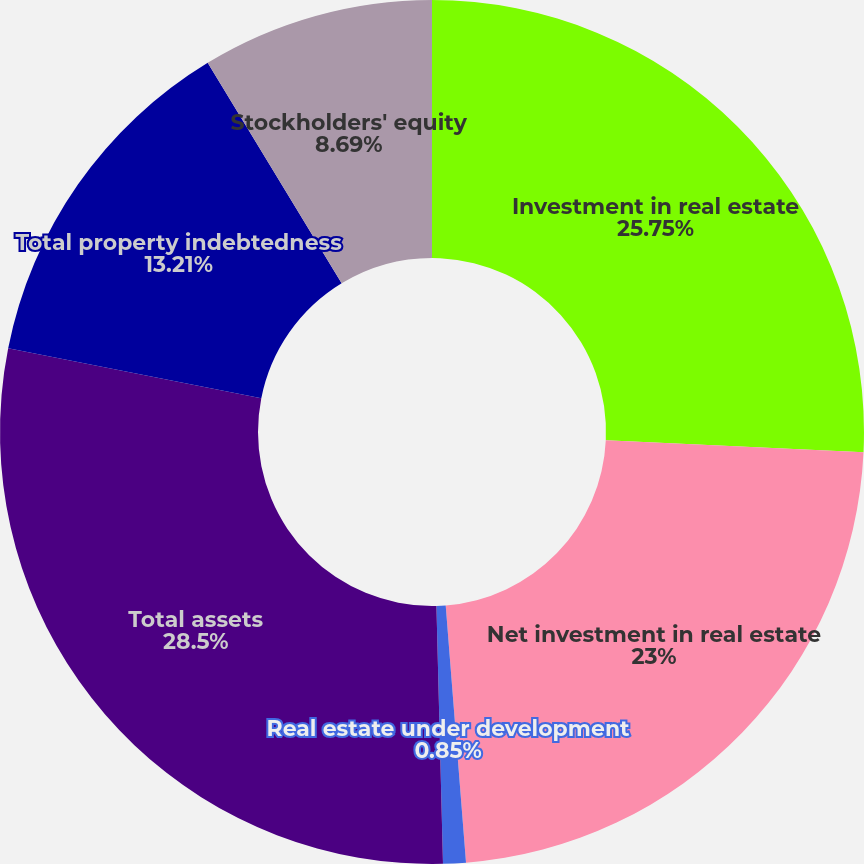Convert chart. <chart><loc_0><loc_0><loc_500><loc_500><pie_chart><fcel>Investment in real estate<fcel>Net investment in real estate<fcel>Real estate under development<fcel>Total assets<fcel>Total property indebtedness<fcel>Stockholders' equity<nl><fcel>25.75%<fcel>23.0%<fcel>0.85%<fcel>28.51%<fcel>13.21%<fcel>8.69%<nl></chart> 